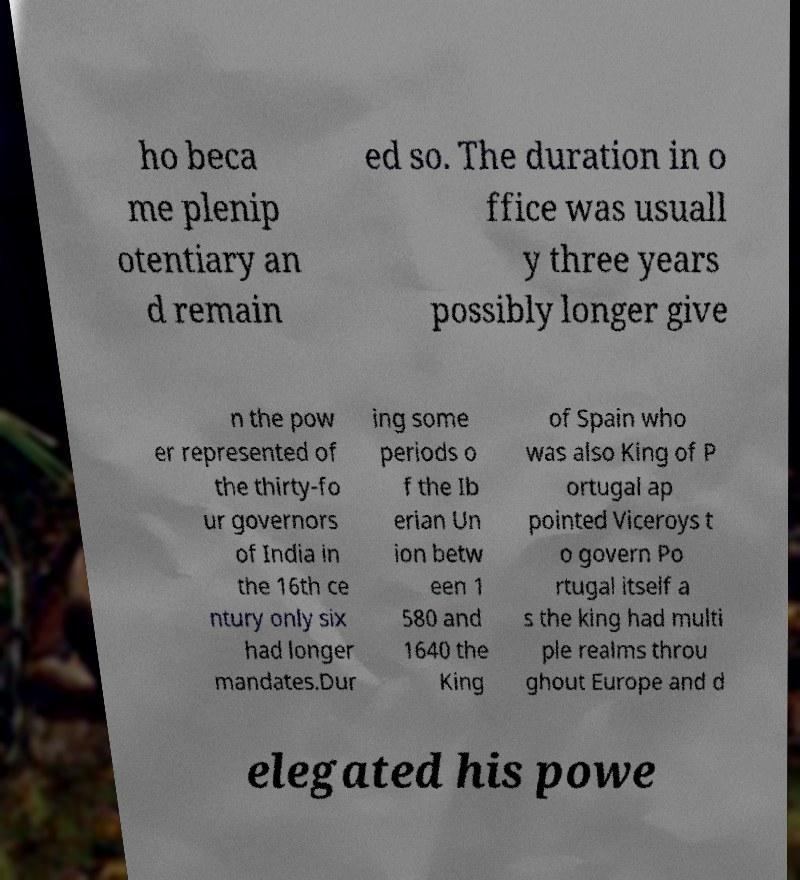Please identify and transcribe the text found in this image. ho beca me plenip otentiary an d remain ed so. The duration in o ffice was usuall y three years possibly longer give n the pow er represented of the thirty-fo ur governors of India in the 16th ce ntury only six had longer mandates.Dur ing some periods o f the Ib erian Un ion betw een 1 580 and 1640 the King of Spain who was also King of P ortugal ap pointed Viceroys t o govern Po rtugal itself a s the king had multi ple realms throu ghout Europe and d elegated his powe 